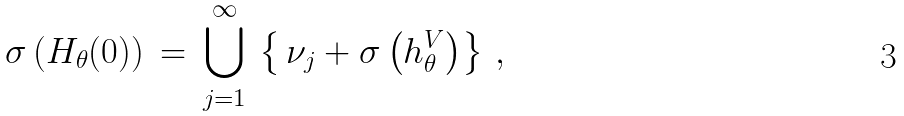<formula> <loc_0><loc_0><loc_500><loc_500>\sigma \left ( H _ { \theta } ( 0 ) \right ) \, = \, \bigcup _ { j = 1 } ^ { \infty } \, \left \{ \, \nu _ { j } + \sigma \left ( h ^ { V } _ { \theta } \right ) \right \} \, ,</formula> 